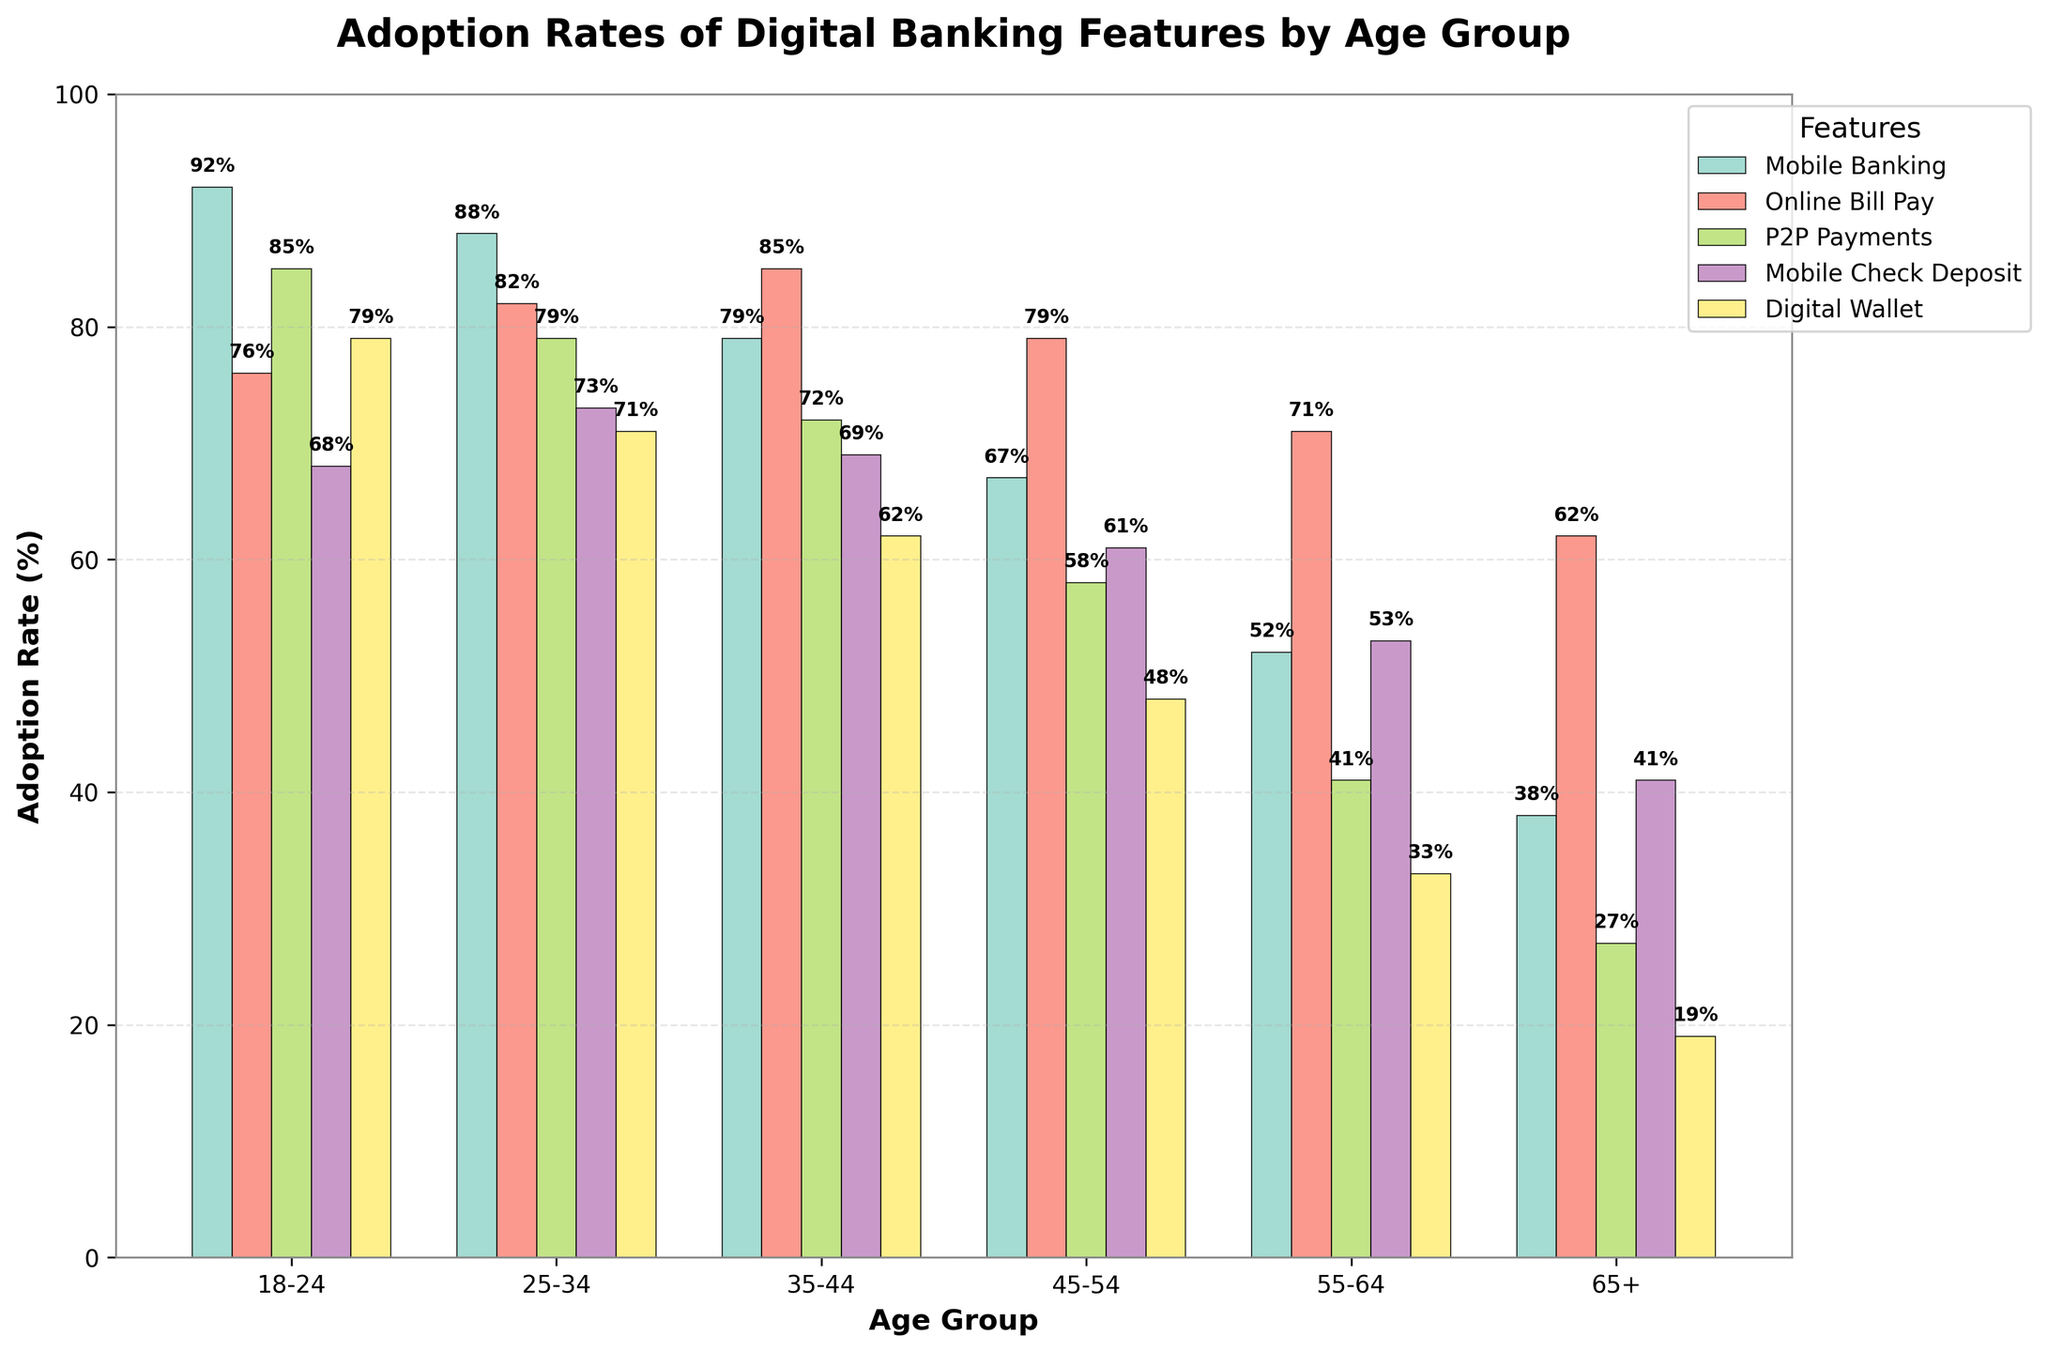Which age group has the highest adoption rate for mobile banking? By looking at the bar chart for mobile banking, we see that the highest bar corresponds to the 18-24 age group.
Answer: 18-24 How does the adoption rate of digital wallets differ between the 18-24 and 65+ age groups? We can compare the heights of the bars for digital wallets between the age groups 18-24 and 65+. The 18-24 group bar is much taller at 79%, while the 65+ group bar is shorter at 19%.
Answer: 60% What is the average adoption rate of online bill pay across all age groups? Sum the adoption rates for online bill pay across all age groups (76%, 82%, 85%, 79%, 71%, 62%) and then divide by the number of age groups (6). The sum is 455%, and the average is 455/6 = 75.83%.
Answer: 75.83% Which feature has the most significant adoption rate drop from the 35-44 age group to the 45-54 age group? We need to look at the differences in each feature's adoption rates between the 35-44 and 45-54 age groups. The differences are: Mobile Banking (-12%), Online Bill Pay (-6%), P2P Payments (-14%), Mobile Check Deposit (-8%), Digital Wallet (-14%). The most significant drop is from P2P Payments and Digital Wallet, both with a 14% drop.
Answer: P2P Payments and Digital Wallet For the 55-64 age group, which digital banking feature has the lowest adoption rate? By observing the bars corresponding to the 55-64 age group, the shortest bar represents Digital Wallet at 33%.
Answer: Digital Wallet What is the combined adoption rate for mobile banking and online bill pay for the 25-34 age group? Add the adoption rates of mobile banking and online bill pay for the 25-34 age group (88% + 82%), which equals 170%.
Answer: 170% Which age group has the smallest gap between the adoption rates of mobile check deposit and digital wallet? Compare the differences for each group: 18-24 (68%-79%=-11), 25-34 (73%-71%=2), 35-44 (69%-62%=7), 45-54 (61%-48%=13), 55-64 (53%-33%=20), 65+ (41%-19%=22). The 25-34 age group has the smallest gap of 2%.
Answer: 25-34 What is the total adoption rate of all features combined for the 65+ age group? Sum the adoption rates of all features for the 65+ age group (38% + 62% + 27% + 41% + 19%). The total is 187%.
Answer: 187% If we look at the trend from the youngest to the oldest age group, how does the adoption rate of mobile banking generally change? Observe the trend in the heights of the bars for mobile banking from the youngest group (18-24) to the oldest group (65+). It consistently decreases: 92%, 88%, 79%, 67%, 52%, 38%.
Answer: Decreases 